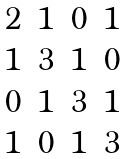Convert formula to latex. <formula><loc_0><loc_0><loc_500><loc_500>\begin{matrix} 2 & 1 & 0 & 1 \\ 1 & 3 & 1 & 0 \\ 0 & 1 & 3 & 1 \\ 1 & 0 & 1 & 3 \end{matrix}</formula> 